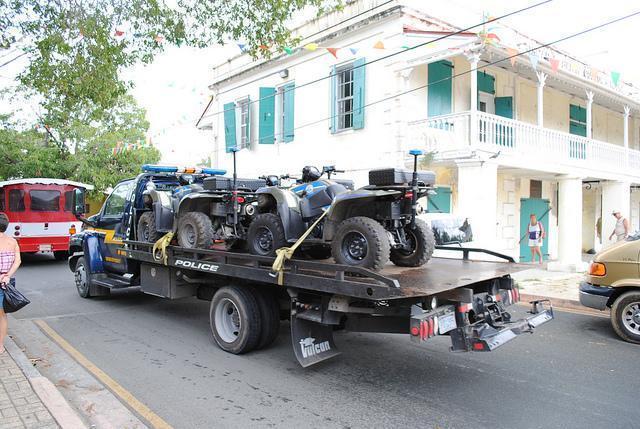The ATVs being carried on the flatbed truck are used by which public agency?
Select the accurate response from the four choices given to answer the question.
Options: Fire department, police, city hall, health department. Police. 